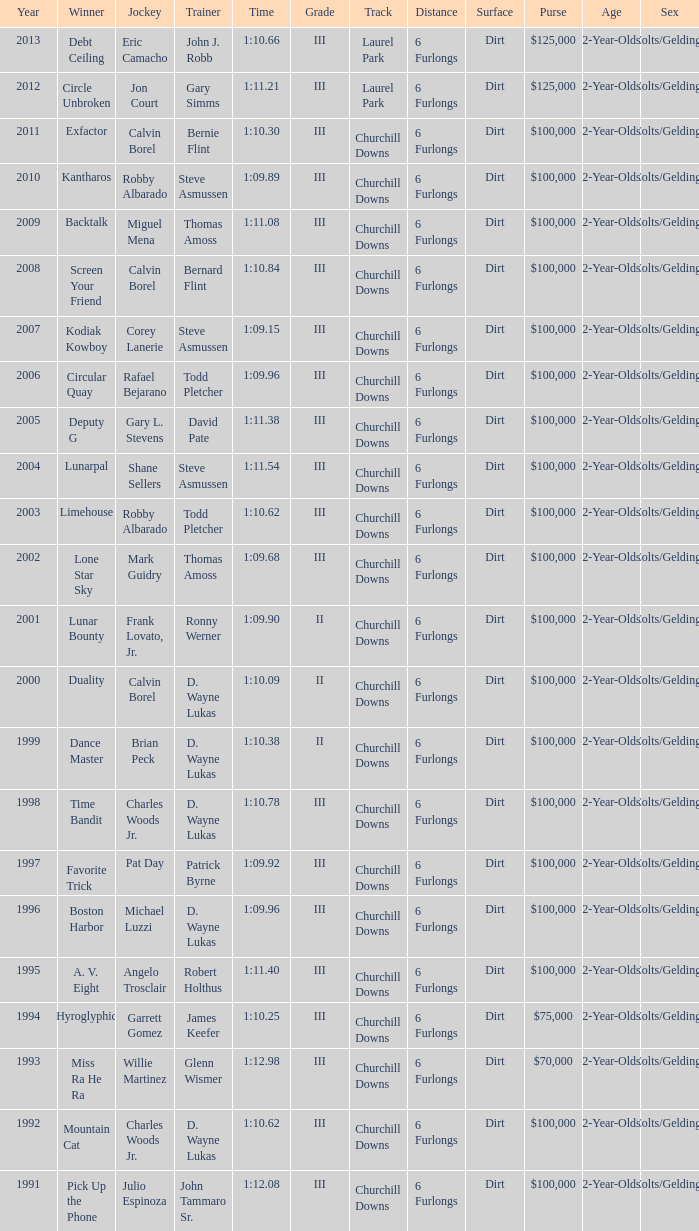What was the duration for screen your friend? 1:10.84. 